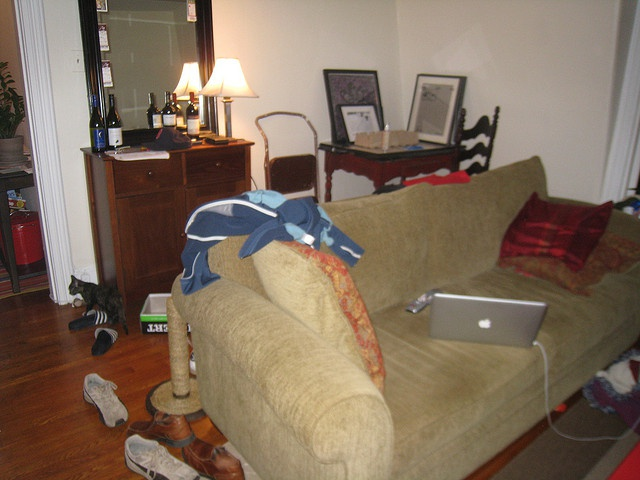Describe the objects in this image and their specific colors. I can see couch in olive, gray, and tan tones, laptop in olive, gray, lightgray, and darkgray tones, chair in olive, black, tan, darkgray, and maroon tones, chair in olive, black, gray, and darkgreen tones, and cat in olive, black, and gray tones in this image. 